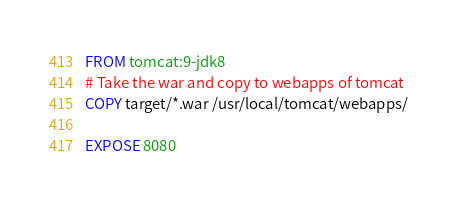Convert code to text. <code><loc_0><loc_0><loc_500><loc_500><_Dockerfile_>FROM tomcat:9-jdk8
# Take the war and copy to webapps of tomcat
COPY target/*.war /usr/local/tomcat/webapps/

EXPOSE 8080
</code> 